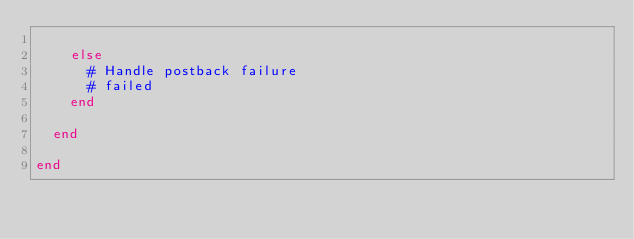<code> <loc_0><loc_0><loc_500><loc_500><_Ruby_>
    else
      # Handle postback failure
      # failed
    end

  end

end</code> 